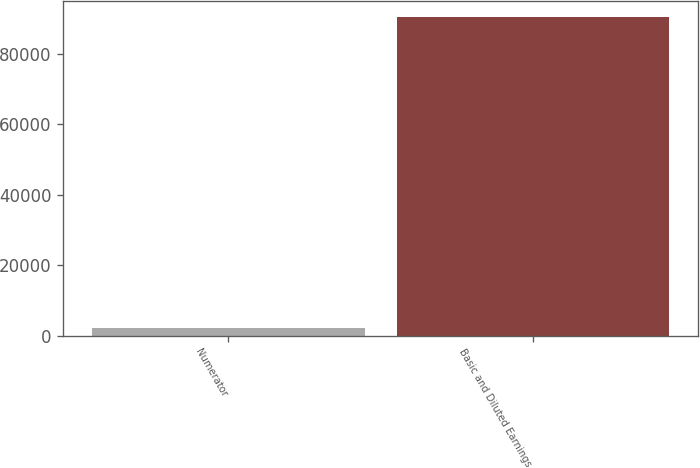Convert chart to OTSL. <chart><loc_0><loc_0><loc_500><loc_500><bar_chart><fcel>Numerator<fcel>Basic and Diluted Earnings<nl><fcel>2017<fcel>90419<nl></chart> 